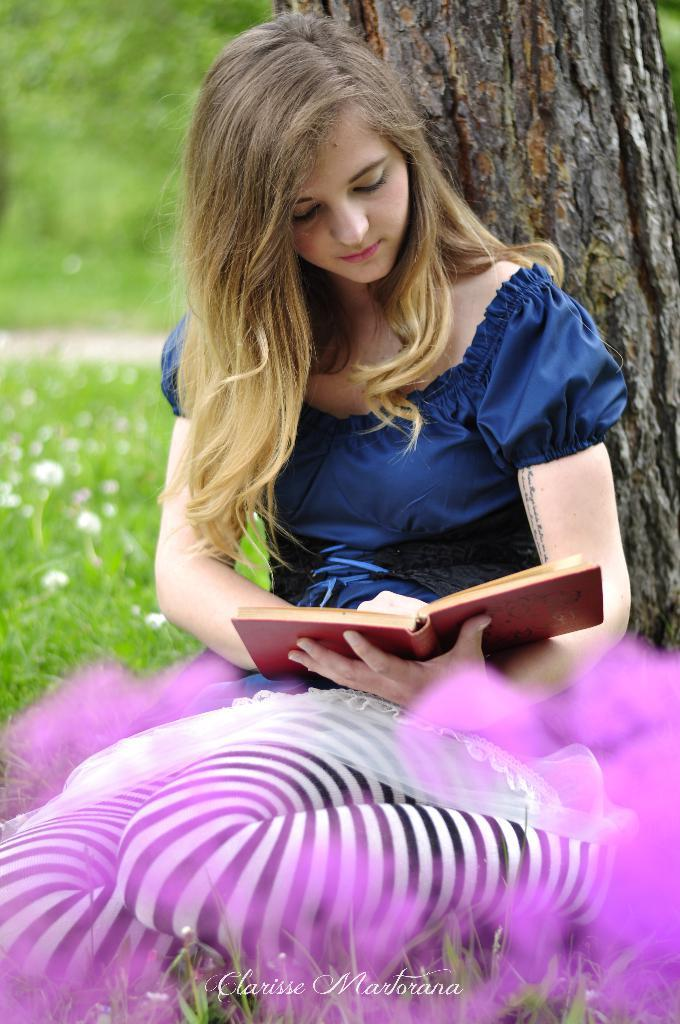What is the lady in the image doing? The lady is sitting in the image. What is the lady holding in the image? The lady is holding a book. What can be seen in the background of the image? There is a tree in the background of the image. What type of vegetation is present at the bottom of the image? Grass is present at the bottom of the image. What type of plants can be seen in the image? Flowers are visible in the image. What type of scarf is the lady wearing in the image? The lady is not wearing a scarf in the image. How many bits can be seen in the image? There are no bits present in the image. 